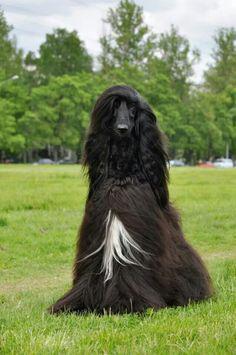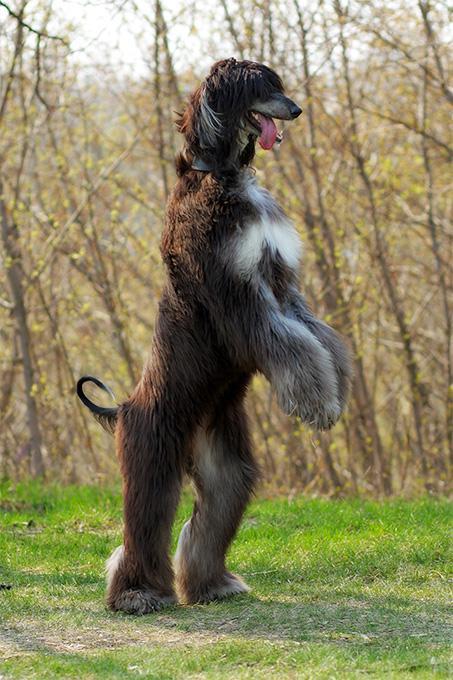The first image is the image on the left, the second image is the image on the right. Given the left and right images, does the statement "One image shows a mostly black dog sitting upright in the grass." hold true? Answer yes or no. Yes. 